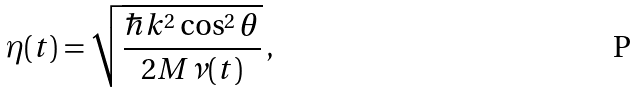Convert formula to latex. <formula><loc_0><loc_0><loc_500><loc_500>\eta ( t ) = \sqrt { \frac { \hbar { k } ^ { 2 } \cos ^ { 2 } \theta } { 2 M \nu ( t ) } } \, ,</formula> 